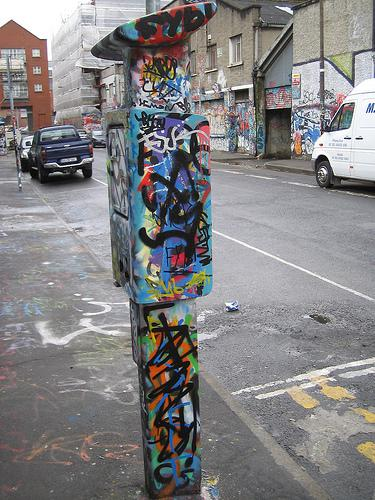Question: what is on the street?
Choices:
A. Trucks.
B. Runners.
C. Cars.
D. Leaves.
Answer with the letter. Answer: C Question: what are the cars on?
Choices:
A. The driveway.
B. The ramp.
C. The street.
D. The truck.
Answer with the letter. Answer: C Question: who will walk by this?
Choices:
A. People.
B. Mourners.
C. Sightseerers.
D. The band.
Answer with the letter. Answer: A 